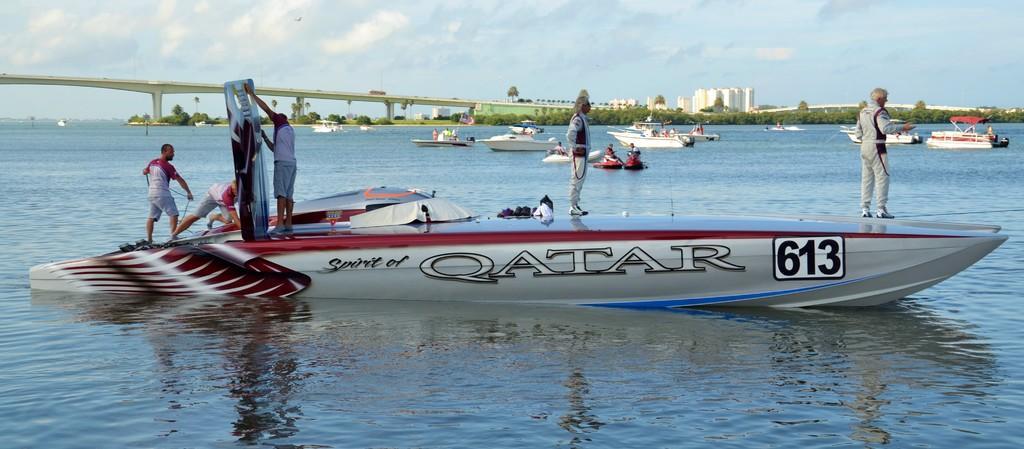In one or two sentences, can you explain what this image depicts? Here in this picture we can see number of boats present in water and in the front we can see number of people standing on the boat and we can also see other people also present in other boats and on the left side we can see a bridge present and we can also see plants and trees in the far and we can see buildings present and we can see clouds in the sky. 